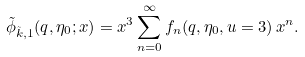<formula> <loc_0><loc_0><loc_500><loc_500>\tilde { \phi } _ { \tilde { k } , 1 } ( q , \eta _ { 0 } ; x ) = x ^ { 3 } \sum _ { n = 0 } ^ { \infty } f _ { n } ( q , \eta _ { 0 } , u = 3 ) \, x ^ { n } .</formula> 